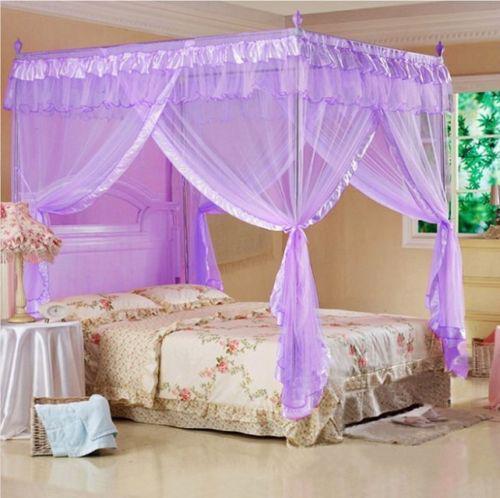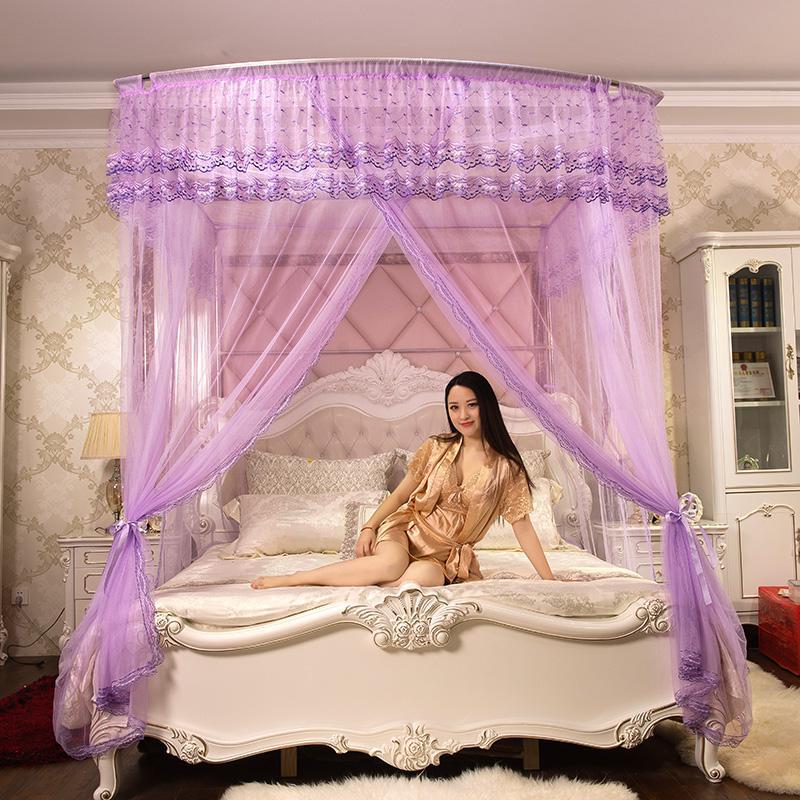The first image is the image on the left, the second image is the image on the right. Analyze the images presented: Is the assertion "One of the images includes a human." valid? Answer yes or no. Yes. The first image is the image on the left, the second image is the image on the right. Evaluate the accuracy of this statement regarding the images: "A brunette woman in a negligee is posed with one of the purple canopy beds.". Is it true? Answer yes or no. Yes. 